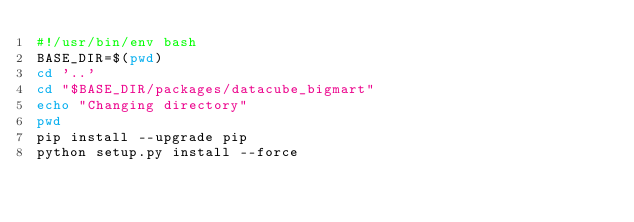Convert code to text. <code><loc_0><loc_0><loc_500><loc_500><_Bash_>#!/usr/bin/env bash
BASE_DIR=$(pwd)
cd '..'
cd "$BASE_DIR/packages/datacube_bigmart"
echo "Changing directory"
pwd
pip install --upgrade pip
python setup.py install --force</code> 